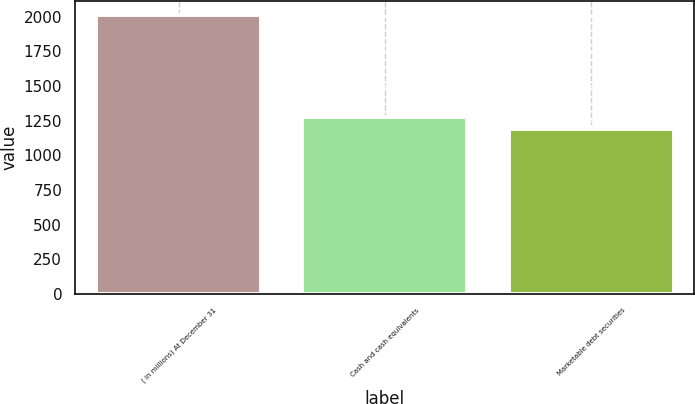<chart> <loc_0><loc_0><loc_500><loc_500><bar_chart><fcel>( in millions) At December 31<fcel>Cash and cash equivalents<fcel>Marketable debt securities<nl><fcel>2012<fcel>1274.63<fcel>1192.7<nl></chart> 